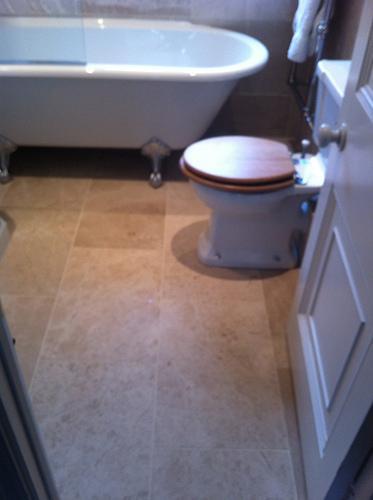How many toilets are there?
Give a very brief answer. 1. 